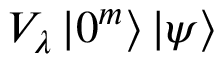<formula> <loc_0><loc_0><loc_500><loc_500>V _ { \lambda } \left | 0 ^ { m } \right \rangle \left | \psi \right \rangle</formula> 